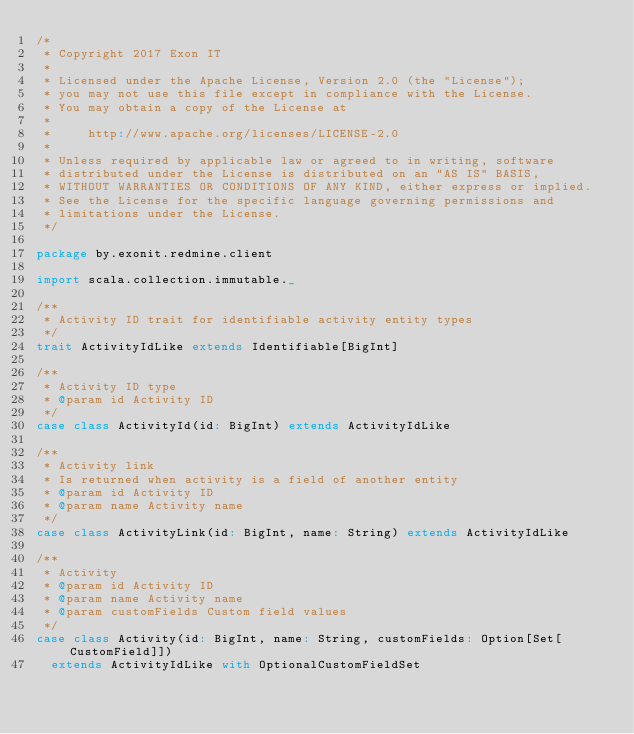<code> <loc_0><loc_0><loc_500><loc_500><_Scala_>/*
 * Copyright 2017 Exon IT
 *
 * Licensed under the Apache License, Version 2.0 (the "License");
 * you may not use this file except in compliance with the License.
 * You may obtain a copy of the License at
 *
 *     http://www.apache.org/licenses/LICENSE-2.0
 *
 * Unless required by applicable law or agreed to in writing, software
 * distributed under the License is distributed on an "AS IS" BASIS,
 * WITHOUT WARRANTIES OR CONDITIONS OF ANY KIND, either express or implied.
 * See the License for the specific language governing permissions and
 * limitations under the License.
 */

package by.exonit.redmine.client

import scala.collection.immutable._

/**
 * Activity ID trait for identifiable activity entity types
 */
trait ActivityIdLike extends Identifiable[BigInt]

/**
 * Activity ID type
 * @param id Activity ID
 */
case class ActivityId(id: BigInt) extends ActivityIdLike

/**
 * Activity link
 * Is returned when activity is a field of another entity
 * @param id Activity ID
 * @param name Activity name
 */
case class ActivityLink(id: BigInt, name: String) extends ActivityIdLike

/**
 * Activity
 * @param id Activity ID
 * @param name Activity name
 * @param customFields Custom field values
 */
case class Activity(id: BigInt, name: String, customFields: Option[Set[CustomField]])
  extends ActivityIdLike with OptionalCustomFieldSet
</code> 